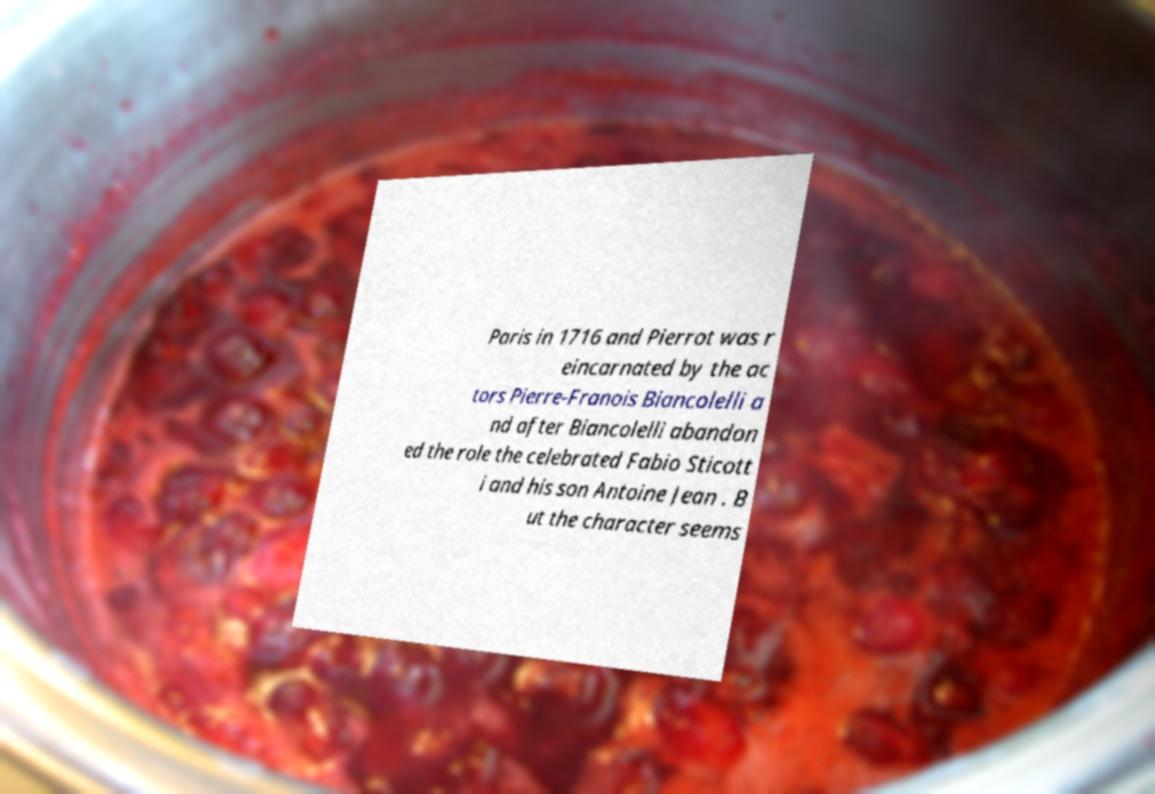Could you extract and type out the text from this image? Paris in 1716 and Pierrot was r eincarnated by the ac tors Pierre-Franois Biancolelli a nd after Biancolelli abandon ed the role the celebrated Fabio Sticott i and his son Antoine Jean . B ut the character seems 